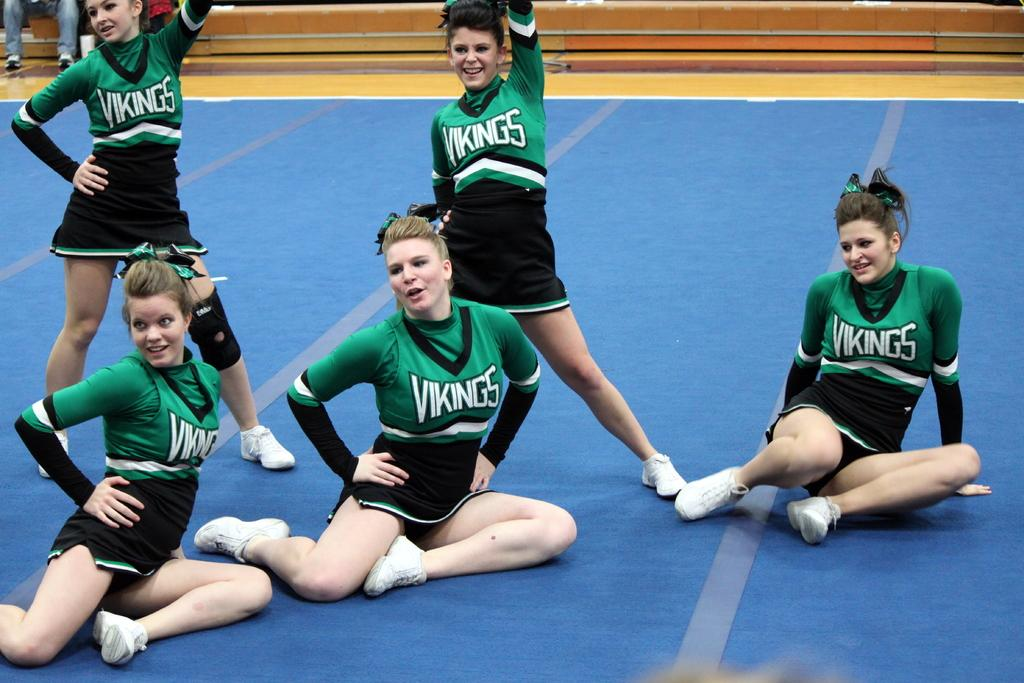How many girls are sitting at the bottom of the image? There are three girls sitting at the bottom of the image. How many girls are standing in the middle of the image? There are two girls standing in the middle of the image. What emotion are the girls expressing in the image? The girls are laughing in the image. What color are the dresses worn by the girls? The girls are wearing green color dresses. What is the name of the girl standing in the middle of the image? There is no information about the names of the girls in the image. 